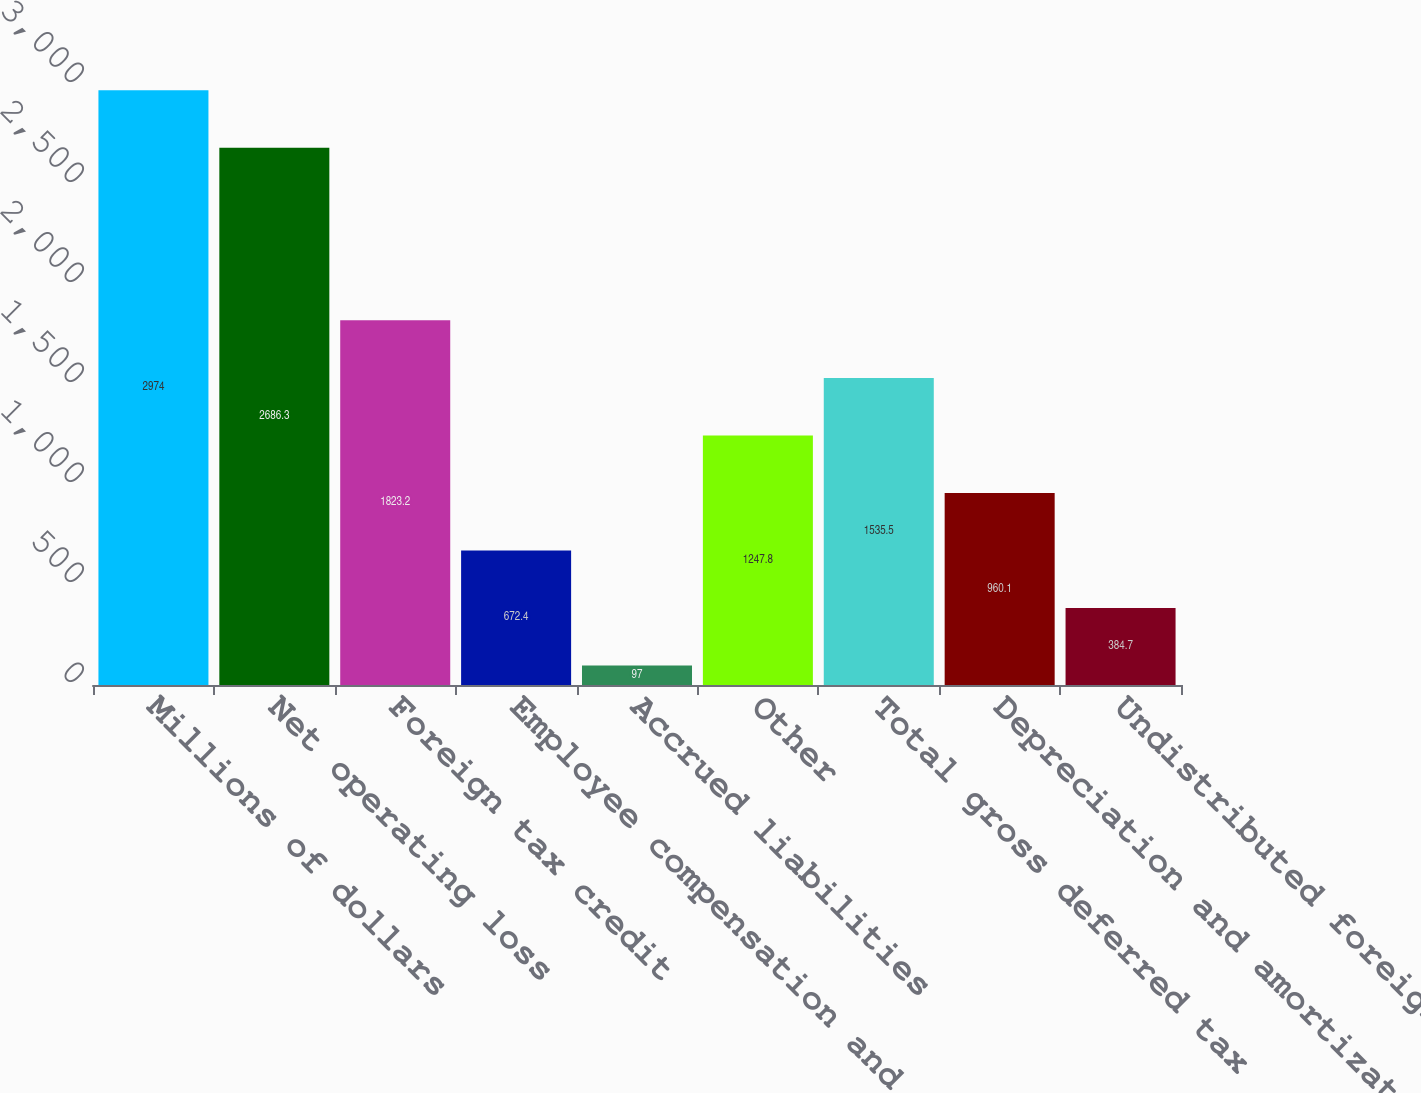Convert chart to OTSL. <chart><loc_0><loc_0><loc_500><loc_500><bar_chart><fcel>Millions of dollars<fcel>Net operating loss<fcel>Foreign tax credit<fcel>Employee compensation and<fcel>Accrued liabilities<fcel>Other<fcel>Total gross deferred tax<fcel>Depreciation and amortization<fcel>Undistributed foreign earnings<nl><fcel>2974<fcel>2686.3<fcel>1823.2<fcel>672.4<fcel>97<fcel>1247.8<fcel>1535.5<fcel>960.1<fcel>384.7<nl></chart> 